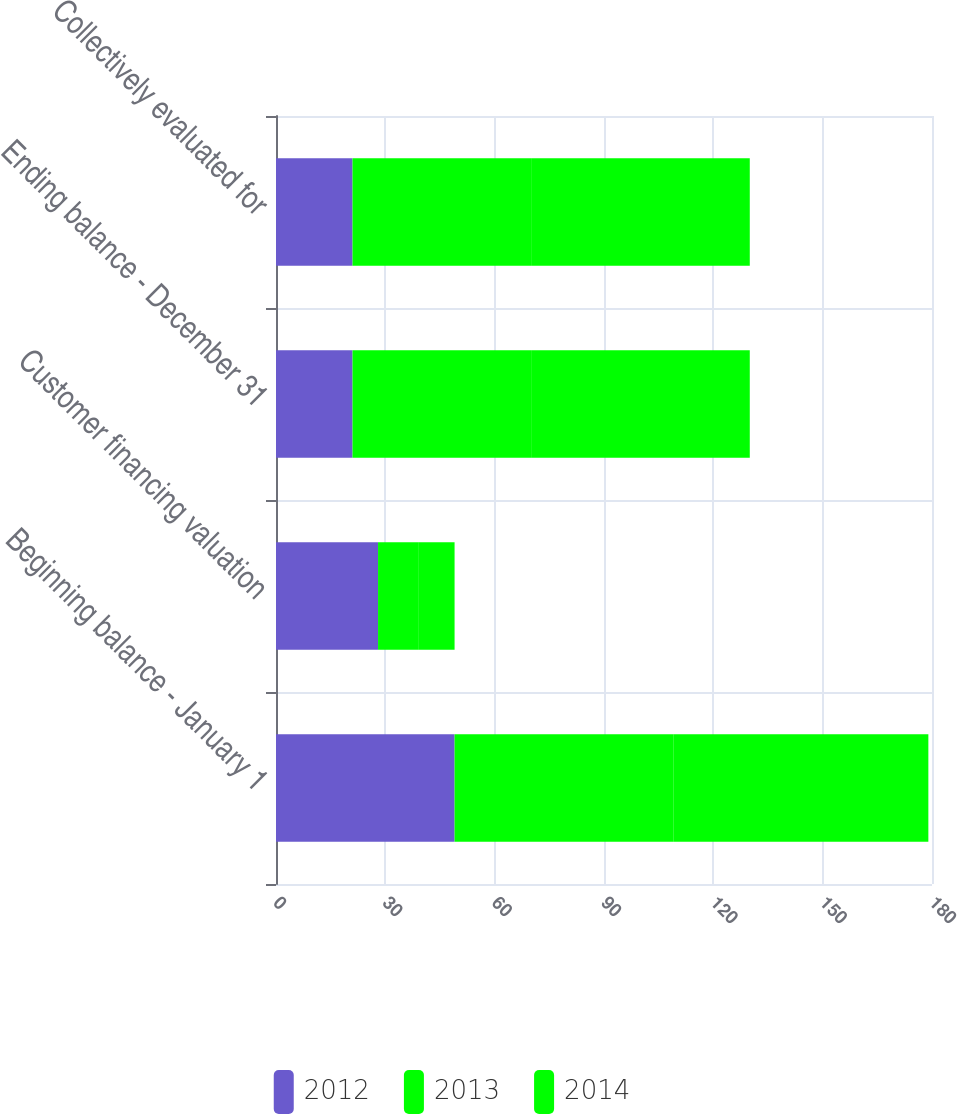Convert chart to OTSL. <chart><loc_0><loc_0><loc_500><loc_500><stacked_bar_chart><ecel><fcel>Beginning balance - January 1<fcel>Customer financing valuation<fcel>Ending balance - December 31<fcel>Collectively evaluated for<nl><fcel>2012<fcel>49<fcel>28<fcel>21<fcel>21<nl><fcel>2013<fcel>60<fcel>11<fcel>49<fcel>49<nl><fcel>2014<fcel>70<fcel>10<fcel>60<fcel>60<nl></chart> 